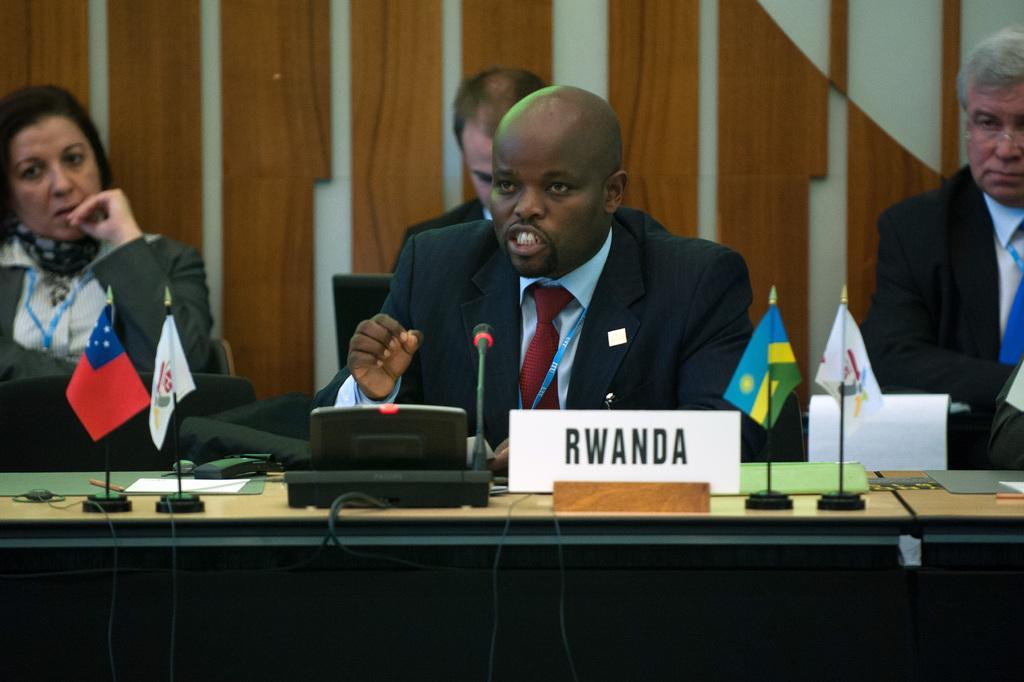How would you summarize this image in a sentence or two? In this image I can see a bench , on top of bench I can see small flags , mike , name plate visible, in front of bench there are four persons sitting on chair , in the background I can see wooden wall. 